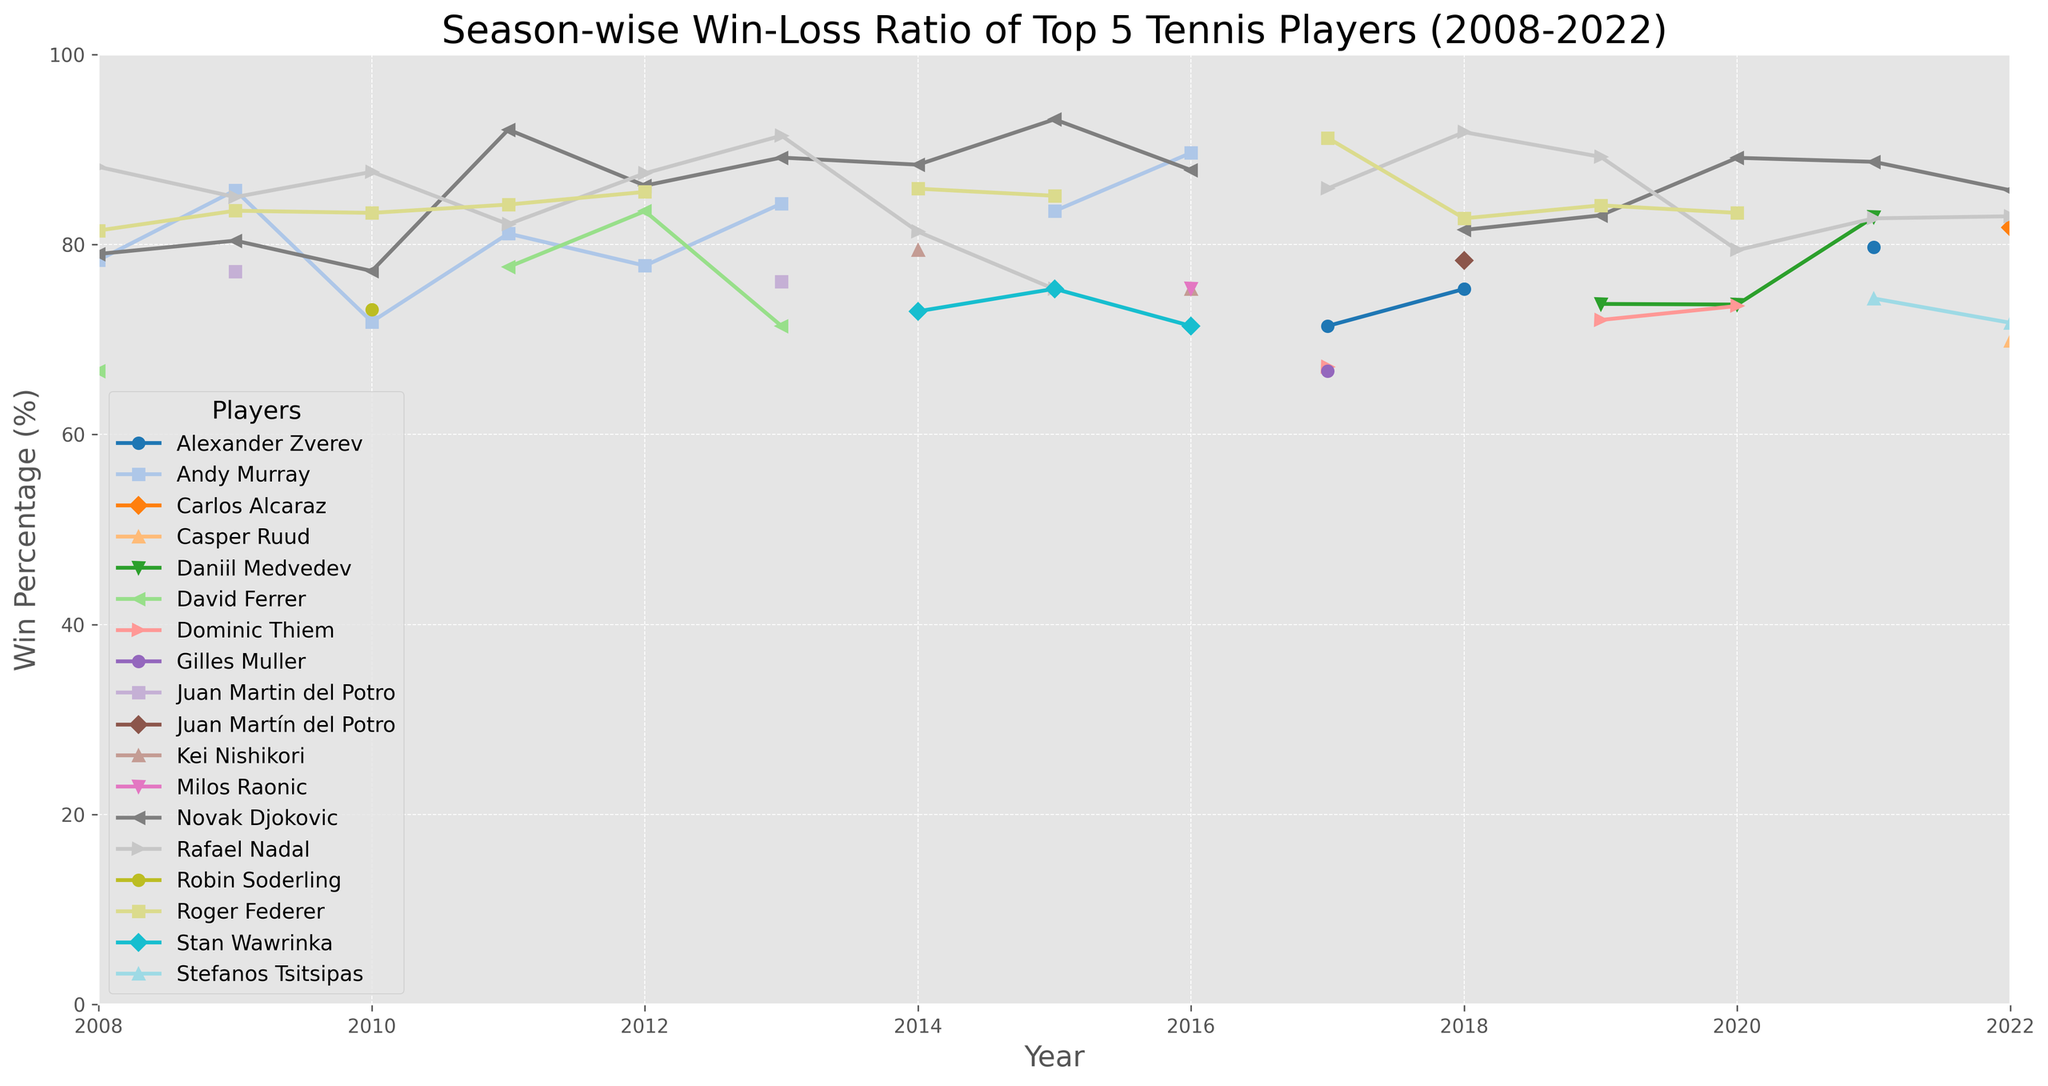Which player had the highest win percentage in 2015? Look for the data point in 2015 and find the highest value among all players.
Answer: Novak Djokovic Which year did Andy Murray achieve his highest win percentage? Examine Andy Murray's line and identify the peak point by checking each year's data.
Answer: 2016 Who had a better win percentage in 2009, Rafael Nadal or Roger Federer? Compare the win percentages of Rafael Nadal and Roger Federer in the year 2009.
Answer: Rafael Nadal What is the average win percentage of Novak Djokovic from 2008 to 2022? Sum all of Novak Djokovic's win percentages from 2008 to 2022 and divide by the total number of years (15).
Answer: \( \frac{64.39 + 79.59 + ... + 85.71}{15} \) = 81.10 (approx) How did Rafael Nadal's win percentage change from 2013 to 2014? Calculate the difference between Rafael Nadal's win percentages for the years 2013 and 2014.
Answer: Decreased by 18.09% Which player's win percentage shows the most significant increase in 2011 compared to 2010? Determine the win percentage changes from 2010 to 2011 for each player and identify the highest increase.
Answer: Novak Djokovic Between 2017 and 2018, did any player's win percentage decrease, and if so, who? Analyze the win percentages for both years for each player and check for any decreases.
Answer: Rafael Nadal In 2022, who had the closest win percentage to Rafael Nadal? Compare Rafael Nadal’s win percentage in 2022 with other players and find the closest value.
Answer: Stefanos Tsitsipas What is the difference between the highest and lowest win percentage for Roger Federer over the given period? Determine the highest and lowest win percentages of Roger Federer and calculate the difference.
Answer: 94.55 - 83.68 = 10.87 Which year shows the most players with win percentages above 70%? Count the number of players with win percentages above 70% for each year and identify the year with the highest count.
Answer: 2015 